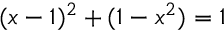Convert formula to latex. <formula><loc_0><loc_0><loc_500><loc_500>( x - 1 ) ^ { 2 } + ( 1 - x ^ { 2 } ) = 1</formula> 